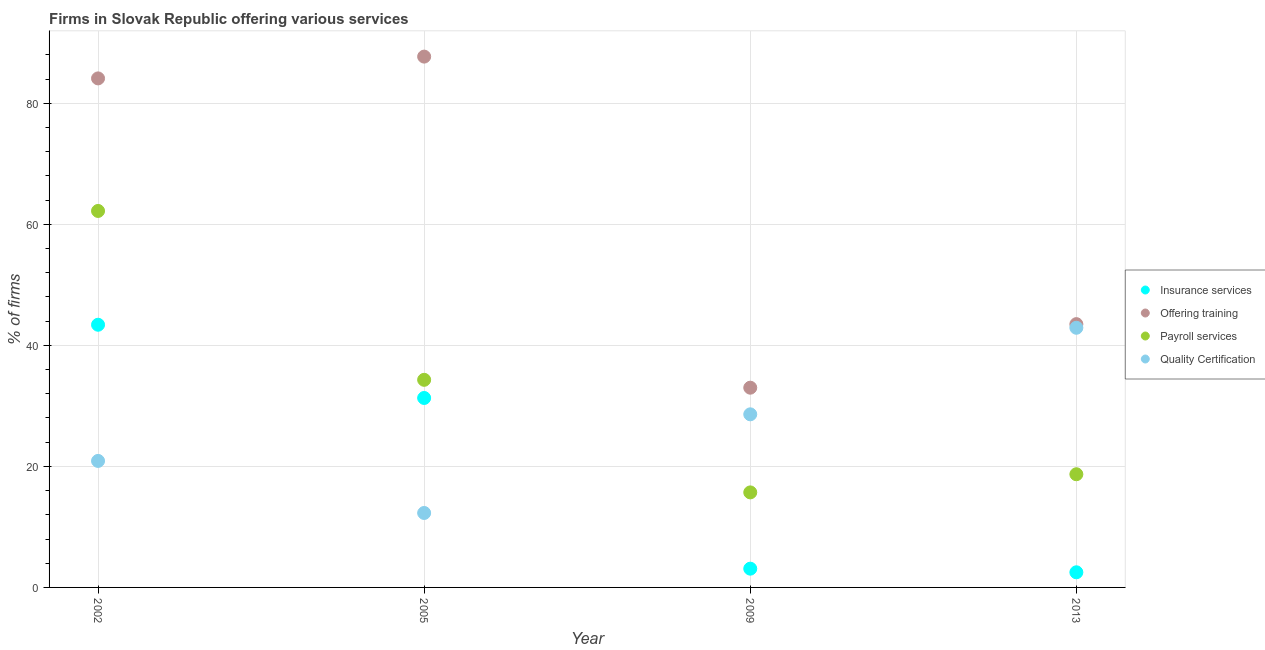What is the percentage of firms offering quality certification in 2009?
Give a very brief answer. 28.6. Across all years, what is the maximum percentage of firms offering insurance services?
Your response must be concise. 43.4. Across all years, what is the minimum percentage of firms offering quality certification?
Provide a succinct answer. 12.3. What is the total percentage of firms offering insurance services in the graph?
Your answer should be compact. 80.3. What is the difference between the percentage of firms offering payroll services in 2013 and the percentage of firms offering training in 2009?
Provide a succinct answer. -14.3. What is the average percentage of firms offering quality certification per year?
Your answer should be very brief. 26.18. In the year 2005, what is the difference between the percentage of firms offering training and percentage of firms offering payroll services?
Provide a succinct answer. 53.4. What is the ratio of the percentage of firms offering insurance services in 2005 to that in 2013?
Ensure brevity in your answer.  12.52. Is the percentage of firms offering quality certification in 2005 less than that in 2009?
Give a very brief answer. Yes. Is the difference between the percentage of firms offering payroll services in 2002 and 2005 greater than the difference between the percentage of firms offering training in 2002 and 2005?
Offer a very short reply. Yes. What is the difference between the highest and the second highest percentage of firms offering training?
Your answer should be very brief. 3.6. What is the difference between the highest and the lowest percentage of firms offering training?
Offer a terse response. 54.7. In how many years, is the percentage of firms offering training greater than the average percentage of firms offering training taken over all years?
Your answer should be very brief. 2. Is the sum of the percentage of firms offering quality certification in 2002 and 2013 greater than the maximum percentage of firms offering training across all years?
Provide a succinct answer. No. Is it the case that in every year, the sum of the percentage of firms offering insurance services and percentage of firms offering payroll services is greater than the sum of percentage of firms offering quality certification and percentage of firms offering training?
Offer a very short reply. No. Is it the case that in every year, the sum of the percentage of firms offering insurance services and percentage of firms offering training is greater than the percentage of firms offering payroll services?
Offer a very short reply. Yes. Does the percentage of firms offering training monotonically increase over the years?
Your response must be concise. No. Is the percentage of firms offering training strictly greater than the percentage of firms offering quality certification over the years?
Provide a short and direct response. Yes. Is the percentage of firms offering quality certification strictly less than the percentage of firms offering payroll services over the years?
Your response must be concise. No. How many years are there in the graph?
Your response must be concise. 4. Are the values on the major ticks of Y-axis written in scientific E-notation?
Provide a succinct answer. No. Does the graph contain grids?
Keep it short and to the point. Yes. Where does the legend appear in the graph?
Offer a terse response. Center right. What is the title of the graph?
Give a very brief answer. Firms in Slovak Republic offering various services . Does "Regional development banks" appear as one of the legend labels in the graph?
Keep it short and to the point. No. What is the label or title of the X-axis?
Ensure brevity in your answer.  Year. What is the label or title of the Y-axis?
Your answer should be compact. % of firms. What is the % of firms in Insurance services in 2002?
Keep it short and to the point. 43.4. What is the % of firms of Offering training in 2002?
Ensure brevity in your answer.  84.1. What is the % of firms in Payroll services in 2002?
Your response must be concise. 62.2. What is the % of firms of Quality Certification in 2002?
Provide a succinct answer. 20.9. What is the % of firms in Insurance services in 2005?
Your response must be concise. 31.3. What is the % of firms in Offering training in 2005?
Provide a short and direct response. 87.7. What is the % of firms in Payroll services in 2005?
Offer a terse response. 34.3. What is the % of firms in Insurance services in 2009?
Offer a very short reply. 3.1. What is the % of firms of Offering training in 2009?
Keep it short and to the point. 33. What is the % of firms of Quality Certification in 2009?
Make the answer very short. 28.6. What is the % of firms in Insurance services in 2013?
Your response must be concise. 2.5. What is the % of firms in Offering training in 2013?
Your response must be concise. 43.5. What is the % of firms in Payroll services in 2013?
Provide a succinct answer. 18.7. What is the % of firms of Quality Certification in 2013?
Provide a short and direct response. 42.9. Across all years, what is the maximum % of firms of Insurance services?
Ensure brevity in your answer.  43.4. Across all years, what is the maximum % of firms in Offering training?
Keep it short and to the point. 87.7. Across all years, what is the maximum % of firms of Payroll services?
Give a very brief answer. 62.2. Across all years, what is the maximum % of firms in Quality Certification?
Keep it short and to the point. 42.9. Across all years, what is the minimum % of firms in Insurance services?
Make the answer very short. 2.5. Across all years, what is the minimum % of firms of Offering training?
Offer a terse response. 33. What is the total % of firms of Insurance services in the graph?
Your answer should be compact. 80.3. What is the total % of firms of Offering training in the graph?
Provide a short and direct response. 248.3. What is the total % of firms in Payroll services in the graph?
Offer a terse response. 130.9. What is the total % of firms of Quality Certification in the graph?
Provide a succinct answer. 104.7. What is the difference between the % of firms in Insurance services in 2002 and that in 2005?
Give a very brief answer. 12.1. What is the difference between the % of firms of Payroll services in 2002 and that in 2005?
Provide a succinct answer. 27.9. What is the difference between the % of firms of Insurance services in 2002 and that in 2009?
Provide a succinct answer. 40.3. What is the difference between the % of firms of Offering training in 2002 and that in 2009?
Offer a terse response. 51.1. What is the difference between the % of firms in Payroll services in 2002 and that in 2009?
Provide a succinct answer. 46.5. What is the difference between the % of firms in Insurance services in 2002 and that in 2013?
Your answer should be compact. 40.9. What is the difference between the % of firms of Offering training in 2002 and that in 2013?
Your response must be concise. 40.6. What is the difference between the % of firms in Payroll services in 2002 and that in 2013?
Offer a terse response. 43.5. What is the difference between the % of firms in Quality Certification in 2002 and that in 2013?
Offer a very short reply. -22. What is the difference between the % of firms in Insurance services in 2005 and that in 2009?
Keep it short and to the point. 28.2. What is the difference between the % of firms in Offering training in 2005 and that in 2009?
Provide a succinct answer. 54.7. What is the difference between the % of firms of Quality Certification in 2005 and that in 2009?
Offer a very short reply. -16.3. What is the difference between the % of firms in Insurance services in 2005 and that in 2013?
Give a very brief answer. 28.8. What is the difference between the % of firms in Offering training in 2005 and that in 2013?
Your answer should be compact. 44.2. What is the difference between the % of firms of Quality Certification in 2005 and that in 2013?
Keep it short and to the point. -30.6. What is the difference between the % of firms of Insurance services in 2009 and that in 2013?
Your response must be concise. 0.6. What is the difference between the % of firms in Quality Certification in 2009 and that in 2013?
Ensure brevity in your answer.  -14.3. What is the difference between the % of firms of Insurance services in 2002 and the % of firms of Offering training in 2005?
Offer a very short reply. -44.3. What is the difference between the % of firms in Insurance services in 2002 and the % of firms in Quality Certification in 2005?
Ensure brevity in your answer.  31.1. What is the difference between the % of firms in Offering training in 2002 and the % of firms in Payroll services in 2005?
Keep it short and to the point. 49.8. What is the difference between the % of firms in Offering training in 2002 and the % of firms in Quality Certification in 2005?
Offer a very short reply. 71.8. What is the difference between the % of firms of Payroll services in 2002 and the % of firms of Quality Certification in 2005?
Provide a short and direct response. 49.9. What is the difference between the % of firms in Insurance services in 2002 and the % of firms in Offering training in 2009?
Offer a very short reply. 10.4. What is the difference between the % of firms of Insurance services in 2002 and the % of firms of Payroll services in 2009?
Offer a very short reply. 27.7. What is the difference between the % of firms of Insurance services in 2002 and the % of firms of Quality Certification in 2009?
Your response must be concise. 14.8. What is the difference between the % of firms of Offering training in 2002 and the % of firms of Payroll services in 2009?
Give a very brief answer. 68.4. What is the difference between the % of firms in Offering training in 2002 and the % of firms in Quality Certification in 2009?
Offer a terse response. 55.5. What is the difference between the % of firms of Payroll services in 2002 and the % of firms of Quality Certification in 2009?
Keep it short and to the point. 33.6. What is the difference between the % of firms in Insurance services in 2002 and the % of firms in Offering training in 2013?
Provide a short and direct response. -0.1. What is the difference between the % of firms of Insurance services in 2002 and the % of firms of Payroll services in 2013?
Ensure brevity in your answer.  24.7. What is the difference between the % of firms in Offering training in 2002 and the % of firms in Payroll services in 2013?
Provide a succinct answer. 65.4. What is the difference between the % of firms in Offering training in 2002 and the % of firms in Quality Certification in 2013?
Keep it short and to the point. 41.2. What is the difference between the % of firms of Payroll services in 2002 and the % of firms of Quality Certification in 2013?
Offer a very short reply. 19.3. What is the difference between the % of firms of Insurance services in 2005 and the % of firms of Quality Certification in 2009?
Your response must be concise. 2.7. What is the difference between the % of firms in Offering training in 2005 and the % of firms in Quality Certification in 2009?
Provide a succinct answer. 59.1. What is the difference between the % of firms in Insurance services in 2005 and the % of firms in Offering training in 2013?
Your answer should be very brief. -12.2. What is the difference between the % of firms in Offering training in 2005 and the % of firms in Quality Certification in 2013?
Ensure brevity in your answer.  44.8. What is the difference between the % of firms of Insurance services in 2009 and the % of firms of Offering training in 2013?
Provide a succinct answer. -40.4. What is the difference between the % of firms of Insurance services in 2009 and the % of firms of Payroll services in 2013?
Give a very brief answer. -15.6. What is the difference between the % of firms in Insurance services in 2009 and the % of firms in Quality Certification in 2013?
Offer a very short reply. -39.8. What is the difference between the % of firms in Offering training in 2009 and the % of firms in Payroll services in 2013?
Offer a very short reply. 14.3. What is the difference between the % of firms of Payroll services in 2009 and the % of firms of Quality Certification in 2013?
Keep it short and to the point. -27.2. What is the average % of firms in Insurance services per year?
Keep it short and to the point. 20.07. What is the average % of firms of Offering training per year?
Your answer should be very brief. 62.08. What is the average % of firms in Payroll services per year?
Your answer should be compact. 32.73. What is the average % of firms in Quality Certification per year?
Ensure brevity in your answer.  26.18. In the year 2002, what is the difference between the % of firms of Insurance services and % of firms of Offering training?
Provide a short and direct response. -40.7. In the year 2002, what is the difference between the % of firms of Insurance services and % of firms of Payroll services?
Make the answer very short. -18.8. In the year 2002, what is the difference between the % of firms in Insurance services and % of firms in Quality Certification?
Your answer should be compact. 22.5. In the year 2002, what is the difference between the % of firms in Offering training and % of firms in Payroll services?
Your answer should be very brief. 21.9. In the year 2002, what is the difference between the % of firms in Offering training and % of firms in Quality Certification?
Your answer should be very brief. 63.2. In the year 2002, what is the difference between the % of firms in Payroll services and % of firms in Quality Certification?
Ensure brevity in your answer.  41.3. In the year 2005, what is the difference between the % of firms in Insurance services and % of firms in Offering training?
Your answer should be very brief. -56.4. In the year 2005, what is the difference between the % of firms in Insurance services and % of firms in Payroll services?
Make the answer very short. -3. In the year 2005, what is the difference between the % of firms in Offering training and % of firms in Payroll services?
Ensure brevity in your answer.  53.4. In the year 2005, what is the difference between the % of firms of Offering training and % of firms of Quality Certification?
Your answer should be compact. 75.4. In the year 2009, what is the difference between the % of firms of Insurance services and % of firms of Offering training?
Your answer should be compact. -29.9. In the year 2009, what is the difference between the % of firms of Insurance services and % of firms of Payroll services?
Ensure brevity in your answer.  -12.6. In the year 2009, what is the difference between the % of firms of Insurance services and % of firms of Quality Certification?
Your answer should be very brief. -25.5. In the year 2009, what is the difference between the % of firms of Payroll services and % of firms of Quality Certification?
Your answer should be compact. -12.9. In the year 2013, what is the difference between the % of firms in Insurance services and % of firms in Offering training?
Offer a terse response. -41. In the year 2013, what is the difference between the % of firms of Insurance services and % of firms of Payroll services?
Offer a terse response. -16.2. In the year 2013, what is the difference between the % of firms in Insurance services and % of firms in Quality Certification?
Your answer should be very brief. -40.4. In the year 2013, what is the difference between the % of firms of Offering training and % of firms of Payroll services?
Provide a short and direct response. 24.8. In the year 2013, what is the difference between the % of firms in Payroll services and % of firms in Quality Certification?
Provide a succinct answer. -24.2. What is the ratio of the % of firms in Insurance services in 2002 to that in 2005?
Make the answer very short. 1.39. What is the ratio of the % of firms of Payroll services in 2002 to that in 2005?
Make the answer very short. 1.81. What is the ratio of the % of firms in Quality Certification in 2002 to that in 2005?
Provide a succinct answer. 1.7. What is the ratio of the % of firms of Offering training in 2002 to that in 2009?
Give a very brief answer. 2.55. What is the ratio of the % of firms of Payroll services in 2002 to that in 2009?
Make the answer very short. 3.96. What is the ratio of the % of firms in Quality Certification in 2002 to that in 2009?
Offer a very short reply. 0.73. What is the ratio of the % of firms in Insurance services in 2002 to that in 2013?
Ensure brevity in your answer.  17.36. What is the ratio of the % of firms in Offering training in 2002 to that in 2013?
Give a very brief answer. 1.93. What is the ratio of the % of firms of Payroll services in 2002 to that in 2013?
Your answer should be compact. 3.33. What is the ratio of the % of firms of Quality Certification in 2002 to that in 2013?
Provide a succinct answer. 0.49. What is the ratio of the % of firms of Insurance services in 2005 to that in 2009?
Your answer should be very brief. 10.1. What is the ratio of the % of firms of Offering training in 2005 to that in 2009?
Offer a terse response. 2.66. What is the ratio of the % of firms in Payroll services in 2005 to that in 2009?
Offer a very short reply. 2.18. What is the ratio of the % of firms of Quality Certification in 2005 to that in 2009?
Your answer should be compact. 0.43. What is the ratio of the % of firms of Insurance services in 2005 to that in 2013?
Provide a succinct answer. 12.52. What is the ratio of the % of firms of Offering training in 2005 to that in 2013?
Offer a terse response. 2.02. What is the ratio of the % of firms of Payroll services in 2005 to that in 2013?
Offer a very short reply. 1.83. What is the ratio of the % of firms in Quality Certification in 2005 to that in 2013?
Provide a succinct answer. 0.29. What is the ratio of the % of firms of Insurance services in 2009 to that in 2013?
Make the answer very short. 1.24. What is the ratio of the % of firms in Offering training in 2009 to that in 2013?
Your answer should be compact. 0.76. What is the ratio of the % of firms of Payroll services in 2009 to that in 2013?
Keep it short and to the point. 0.84. What is the difference between the highest and the second highest % of firms in Insurance services?
Offer a terse response. 12.1. What is the difference between the highest and the second highest % of firms in Offering training?
Your answer should be compact. 3.6. What is the difference between the highest and the second highest % of firms in Payroll services?
Provide a succinct answer. 27.9. What is the difference between the highest and the second highest % of firms of Quality Certification?
Offer a very short reply. 14.3. What is the difference between the highest and the lowest % of firms in Insurance services?
Your answer should be very brief. 40.9. What is the difference between the highest and the lowest % of firms of Offering training?
Offer a very short reply. 54.7. What is the difference between the highest and the lowest % of firms in Payroll services?
Keep it short and to the point. 46.5. What is the difference between the highest and the lowest % of firms in Quality Certification?
Your response must be concise. 30.6. 